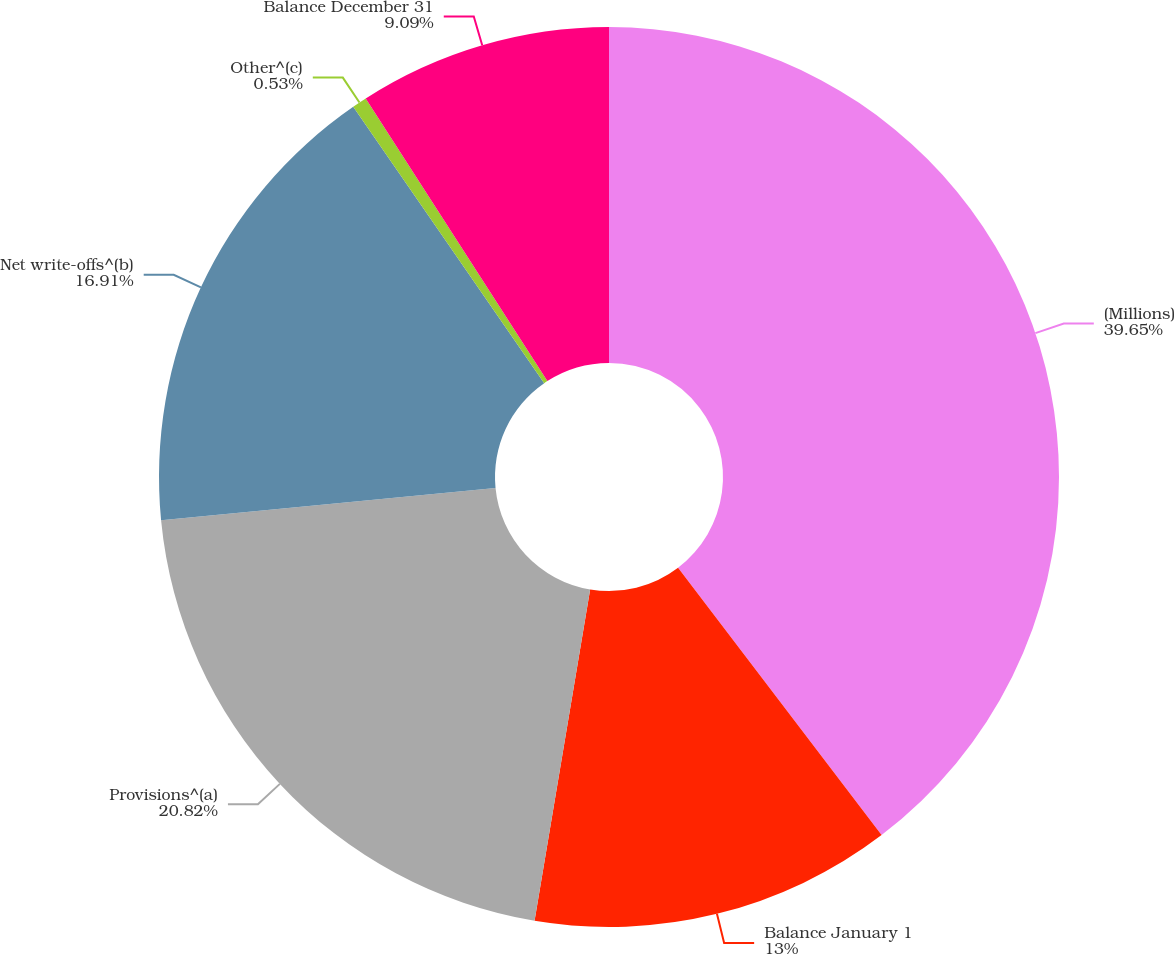<chart> <loc_0><loc_0><loc_500><loc_500><pie_chart><fcel>(Millions)<fcel>Balance January 1<fcel>Provisions^(a)<fcel>Net write-offs^(b)<fcel>Other^(c)<fcel>Balance December 31<nl><fcel>39.64%<fcel>13.0%<fcel>20.82%<fcel>16.91%<fcel>0.53%<fcel>9.09%<nl></chart> 